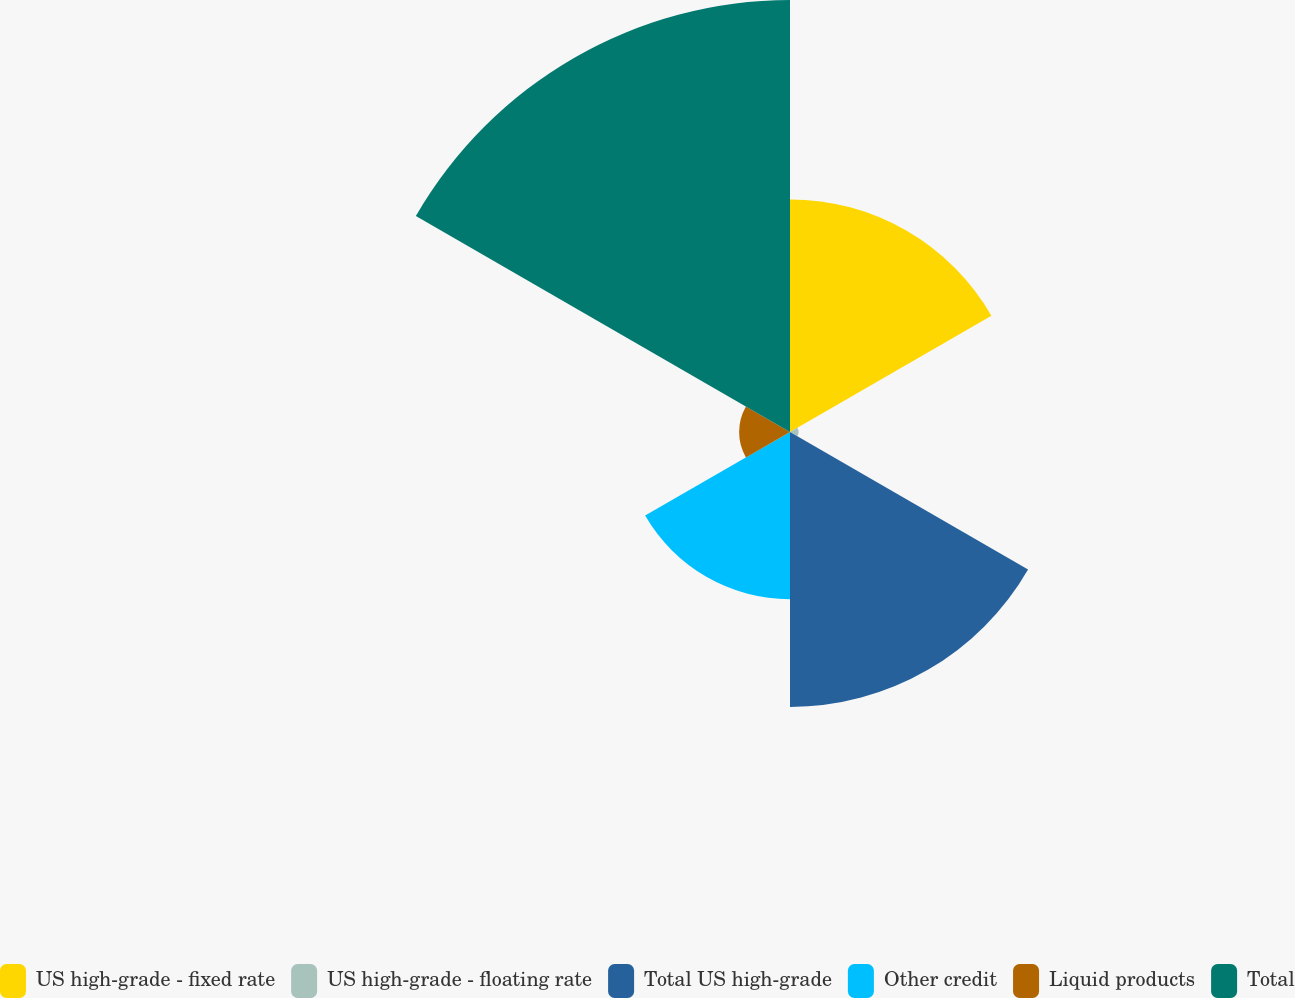Convert chart to OTSL. <chart><loc_0><loc_0><loc_500><loc_500><pie_chart><fcel>US high-grade - fixed rate<fcel>US high-grade - floating rate<fcel>Total US high-grade<fcel>Other credit<fcel>Liquid products<fcel>Total<nl><fcel>19.94%<fcel>0.73%<fcel>23.57%<fcel>14.34%<fcel>4.36%<fcel>37.04%<nl></chart> 